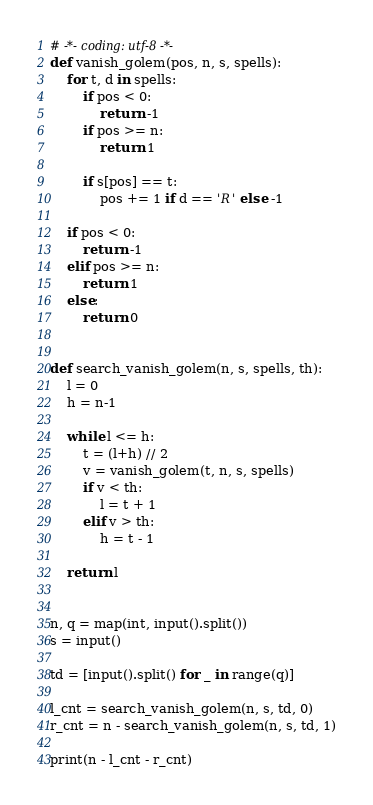Convert code to text. <code><loc_0><loc_0><loc_500><loc_500><_Python_># -*- coding: utf-8 -*-
def vanish_golem(pos, n, s, spells):
    for t, d in spells:
        if pos < 0:
            return -1
        if pos >= n:
            return 1

        if s[pos] == t:
            pos += 1 if d == 'R' else -1

    if pos < 0:
        return -1
    elif pos >= n:
        return 1
    else:
        return 0


def search_vanish_golem(n, s, spells, th):
    l = 0
    h = n-1

    while l <= h:
        t = (l+h) // 2
        v = vanish_golem(t, n, s, spells)
        if v < th:
            l = t + 1
        elif v > th:
            h = t - 1

    return l


n, q = map(int, input().split())
s = input()

td = [input().split() for _ in range(q)]

l_cnt = search_vanish_golem(n, s, td, 0)
r_cnt = n - search_vanish_golem(n, s, td, 1)

print(n - l_cnt - r_cnt)
</code> 